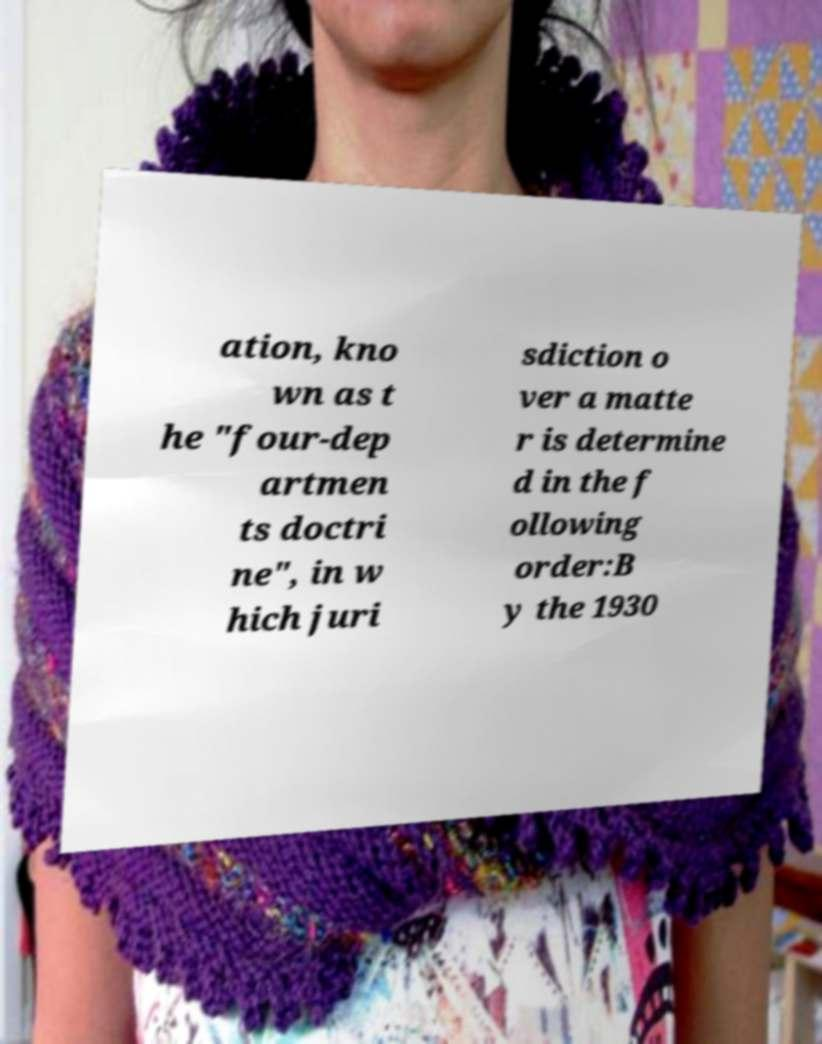Can you read and provide the text displayed in the image?This photo seems to have some interesting text. Can you extract and type it out for me? ation, kno wn as t he "four-dep artmen ts doctri ne", in w hich juri sdiction o ver a matte r is determine d in the f ollowing order:B y the 1930 